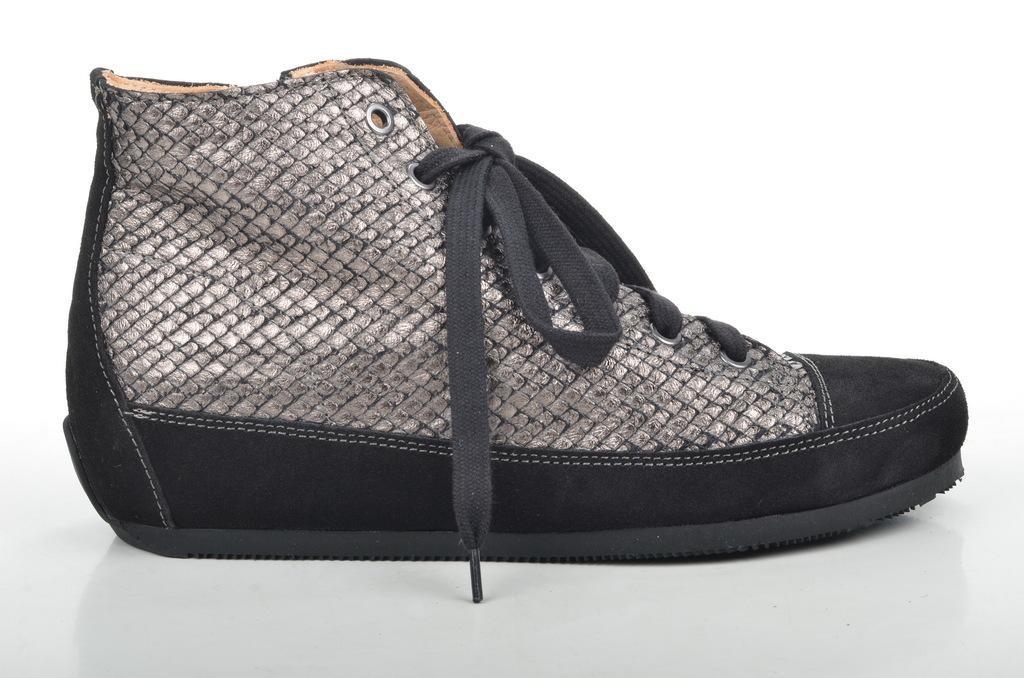What is the main subject of the picture? The main subject of the picture is a shoe. Can you describe the shoe in the image? The shoe is black in color. What color is the background of the image? The background of the image is white. How many bottles of ink can be seen in the image? There are no bottles of ink present in the image; it features a black shoe on a white background. Is your uncle present in the image? There is no person, including your uncle, present in the image; it only features a black shoe on a white background. 